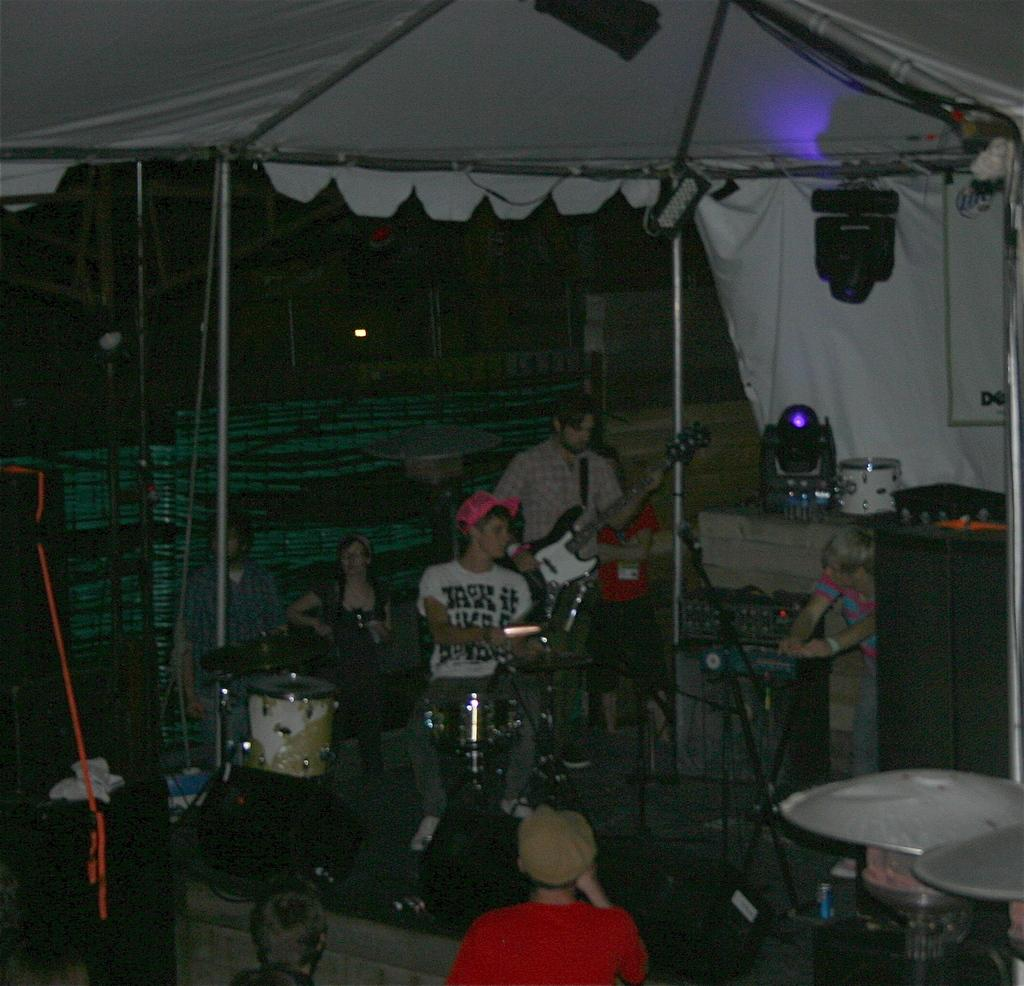What structure can be seen in the image? There is a tent in the image. What is happening inside the tent? There are people inside the tent, and they are accompanied by musical instruments and a speaker. Can you describe the lighting in the image? There is a light on the right side of the image. What type of feather can be seen on top of the tent in the image? There is no feather present on top of the tent in the image. How many crows are sitting on the light in the image? There are no crows present in the image; the light is not accompanied by any birds. 